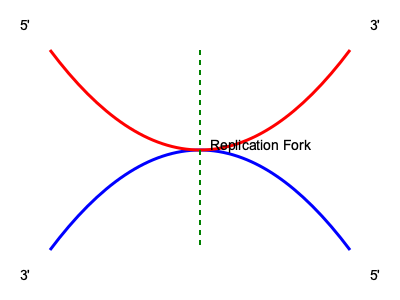In DNA replication, why does the lagging strand synthesis occur in discontinuous segments called Okazaki fragments, while the leading strand is synthesized continuously? To understand this, let's break down the process of DNA replication:

1. DNA structure: DNA is a double-helix molecule with two antiparallel strands. One strand runs 5' to 3', and the other 3' to 5'.

2. DNA polymerase: This enzyme can only add nucleotides to the 3' end of a growing DNA strand.

3. Replication direction: DNA is always synthesized in the 5' to 3' direction.

4. Replication fork: As the double helix unwinds, it forms a Y-shaped structure called the replication fork.

5. Leading strand: One template strand (3' to 5') allows for continuous synthesis in the 5' to 3' direction, matching the overall direction of fork movement.

6. Lagging strand: The other template strand (5' to 3') forces synthesis to occur in the opposite direction of fork movement.

7. Okazaki fragments: To resolve this, the lagging strand is synthesized in short segments (Okazaki fragments) that are later joined together.

8. Primers: Each Okazaki fragment requires a new RNA primer for DNA polymerase to begin synthesis.

9. Discontinuous synthesis: This process of repeatedly laying down primers and synthesizing short fragments results in discontinuous synthesis on the lagging strand.

The continuous synthesis of the leading strand and discontinuous synthesis of the lagging strand allow both strands to be replicated simultaneously despite the unidirectional nature of DNA polymerase.
Answer: DNA polymerase can only synthesize DNA in the 5' to 3' direction, necessitating discontinuous synthesis on the lagging strand. 